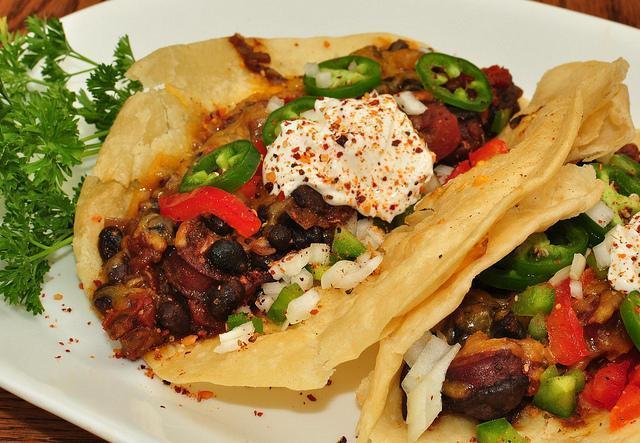How many Jalapenos are on the taco on the left?
Give a very brief answer. 4. 